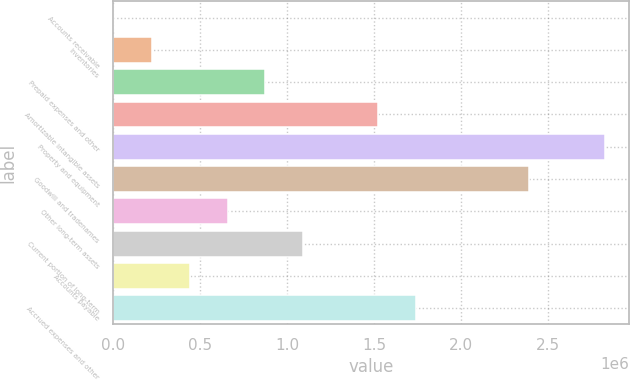<chart> <loc_0><loc_0><loc_500><loc_500><bar_chart><fcel>Accounts receivable<fcel>Inventories<fcel>Prepaid expenses and other<fcel>Amortizable intangible assets<fcel>Property and equipment<fcel>Goodwill and tradenames<fcel>Other long-term assets<fcel>Current portion of long-term<fcel>Accounts payable<fcel>Accrued expenses and other<nl><fcel>6916<fcel>223728<fcel>874165<fcel>1.5246e+06<fcel>2.82548e+06<fcel>2.39185e+06<fcel>657353<fcel>1.09098e+06<fcel>440541<fcel>1.74141e+06<nl></chart> 